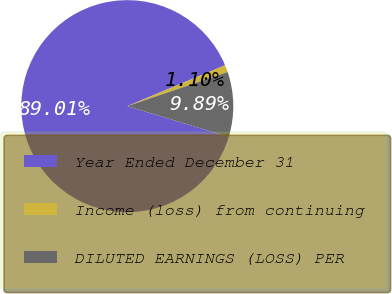Convert chart. <chart><loc_0><loc_0><loc_500><loc_500><pie_chart><fcel>Year Ended December 31<fcel>Income (loss) from continuing<fcel>DILUTED EARNINGS (LOSS) PER<nl><fcel>89.0%<fcel>1.1%<fcel>9.89%<nl></chart> 